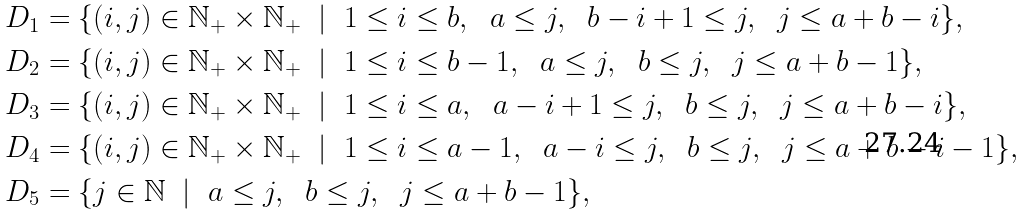Convert formula to latex. <formula><loc_0><loc_0><loc_500><loc_500>D _ { 1 } & = \{ ( i , j ) \in \mathbb { N } _ { + } \times \mathbb { N } _ { + } \ \ | \ \ 1 \leq i \leq b , \ \ a \leq j , \ \ b - i + 1 \leq j , \ \ j \leq a + b - i \} , \\ D _ { 2 } & = \{ ( i , j ) \in \mathbb { N } _ { + } \times \mathbb { N } _ { + } \ \ | \ \ 1 \leq i \leq b - 1 , \ \ a \leq j , \ \ b \leq j , \ \ j \leq a + b - 1 \} , \\ D _ { 3 } & = \{ ( i , j ) \in \mathbb { N } _ { + } \times \mathbb { N } _ { + } \ \ | \ \ 1 \leq i \leq a , \ \ a - i + 1 \leq j , \ \ b \leq j , \ \ j \leq a + b - i \} , \\ D _ { 4 } & = \{ ( i , j ) \in \mathbb { N } _ { + } \times \mathbb { N } _ { + } \ \ | \ \ 1 \leq i \leq a - 1 , \ \ a - i \leq j , \ \ b \leq j , \ \ j \leq a + b - i - 1 \} , \\ D _ { 5 } & = \{ j \in \mathbb { N } \ \ | \ \ a \leq j , \ \ b \leq j , \ \ j \leq a + b - 1 \} ,</formula> 